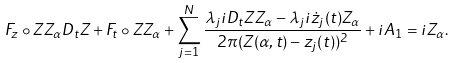<formula> <loc_0><loc_0><loc_500><loc_500>F _ { z } \circ Z Z _ { \alpha } D _ { t } Z + F _ { t } \circ Z Z _ { \alpha } + \sum _ { j = 1 } ^ { N } \frac { \lambda _ { j } i D _ { t } Z Z _ { \alpha } - \lambda _ { j } i \dot { z } _ { j } ( t ) Z _ { \alpha } } { 2 \pi ( Z ( \alpha , t ) - z _ { j } ( t ) ) ^ { 2 } } + i A _ { 1 } = i Z _ { \alpha } .</formula> 